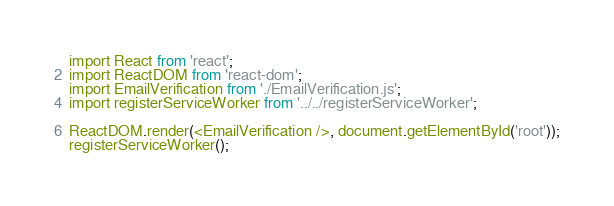<code> <loc_0><loc_0><loc_500><loc_500><_JavaScript_>import React from 'react';
import ReactDOM from 'react-dom';
import EmailVerification from './EmailVerification.js';
import registerServiceWorker from '../../registerServiceWorker';

ReactDOM.render(<EmailVerification />, document.getElementById('root'));
registerServiceWorker();
</code> 